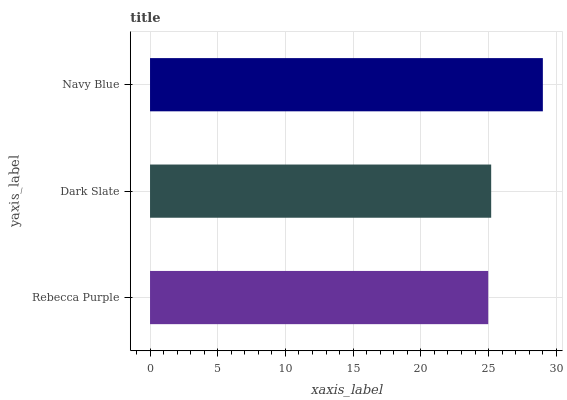Is Rebecca Purple the minimum?
Answer yes or no. Yes. Is Navy Blue the maximum?
Answer yes or no. Yes. Is Dark Slate the minimum?
Answer yes or no. No. Is Dark Slate the maximum?
Answer yes or no. No. Is Dark Slate greater than Rebecca Purple?
Answer yes or no. Yes. Is Rebecca Purple less than Dark Slate?
Answer yes or no. Yes. Is Rebecca Purple greater than Dark Slate?
Answer yes or no. No. Is Dark Slate less than Rebecca Purple?
Answer yes or no. No. Is Dark Slate the high median?
Answer yes or no. Yes. Is Dark Slate the low median?
Answer yes or no. Yes. Is Rebecca Purple the high median?
Answer yes or no. No. Is Navy Blue the low median?
Answer yes or no. No. 